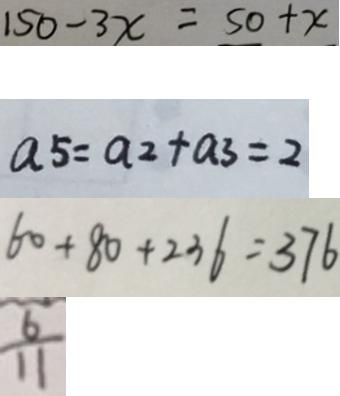<formula> <loc_0><loc_0><loc_500><loc_500>1 5 0 - 3 x = 5 0 + x 
 a 5 = a 2 + a 3 = 2 
 6 0 + 8 0 + 2 3 6 = 3 7 6 
 \frac { 6 } { 1 1 }</formula> 